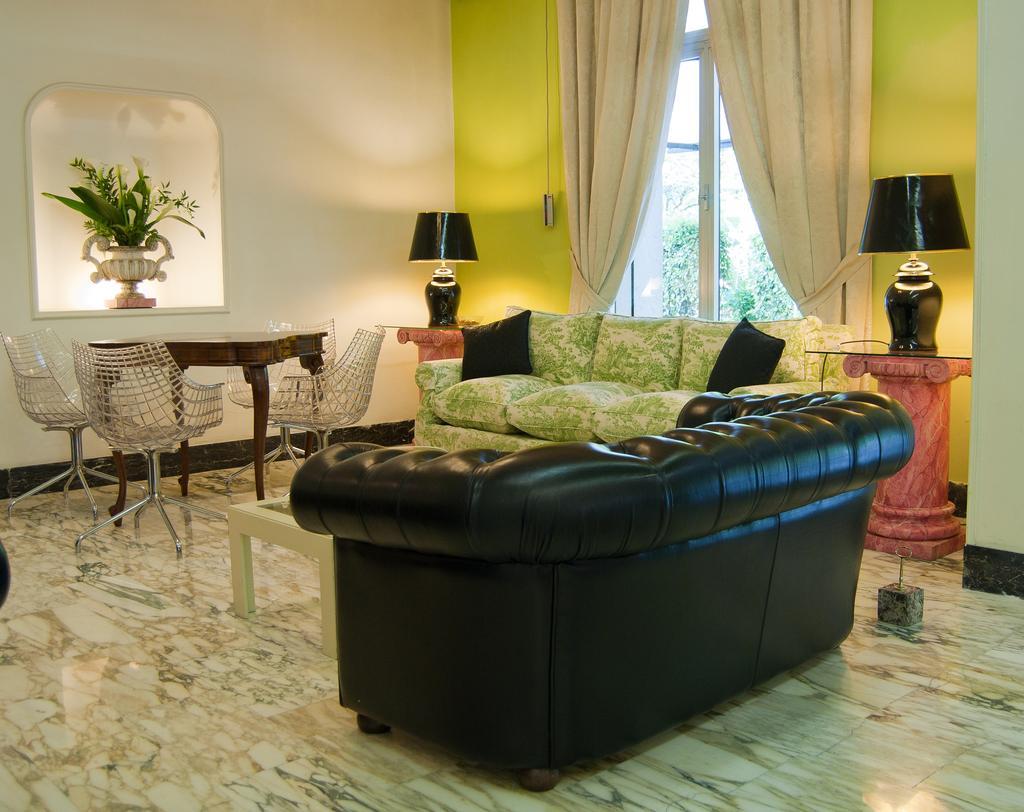Could you give a brief overview of what you see in this image? There are two sofas,two lamps,a table and another table with four chairs in a living room. 